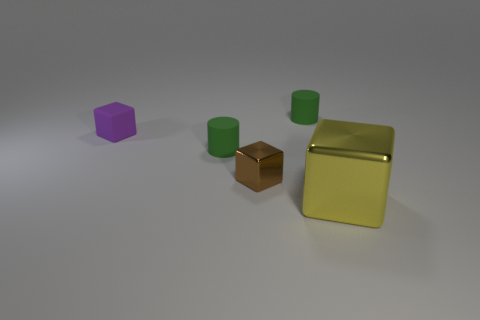Add 4 small purple rubber cubes. How many objects exist? 9 Subtract all cylinders. How many objects are left? 3 Subtract 0 red spheres. How many objects are left? 5 Subtract all rubber cylinders. Subtract all green matte objects. How many objects are left? 1 Add 3 big metal blocks. How many big metal blocks are left? 4 Add 3 blue matte cylinders. How many blue matte cylinders exist? 3 